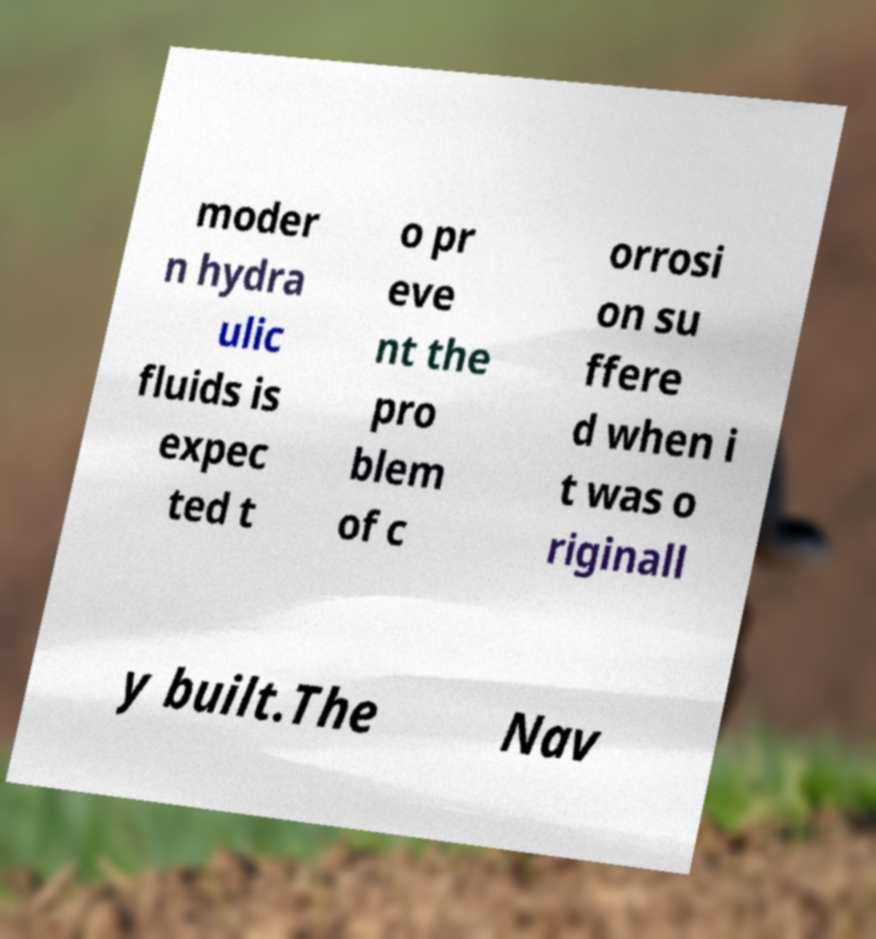There's text embedded in this image that I need extracted. Can you transcribe it verbatim? moder n hydra ulic fluids is expec ted t o pr eve nt the pro blem of c orrosi on su ffere d when i t was o riginall y built.The Nav 